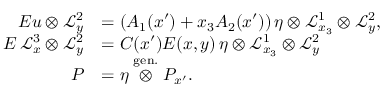<formula> <loc_0><loc_0><loc_500><loc_500>\begin{array} { r l } { E u \otimes \mathcal { L } _ { y } ^ { 2 } } & { = \left ( A _ { 1 } ( x ^ { \prime } ) + x _ { 3 } A _ { 2 } ( x ^ { \prime } ) \right ) \eta \otimes \mathcal { L } _ { x _ { 3 } } ^ { 1 } \otimes \mathcal { L } _ { y } ^ { 2 } , } \\ { E \, \mathcal { L } _ { x } ^ { 3 } \otimes \mathcal { L } _ { y } ^ { 2 } } & { = C ( x ^ { \prime } ) E ( x , y ) \, \eta \otimes \mathcal { L } _ { x _ { 3 } } ^ { 1 } \otimes \mathcal { L } _ { y } ^ { 2 } } \\ { P } & { = \eta \stackrel { g e n . } { \otimes } P _ { x ^ { \prime } } . } \end{array}</formula> 